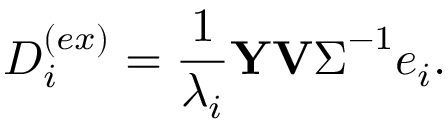<formula> <loc_0><loc_0><loc_500><loc_500>D _ { i } ^ { ( e x ) } = \frac { 1 } { \lambda _ { i } } Y V \Sigma ^ { - 1 } e _ { i } .</formula> 